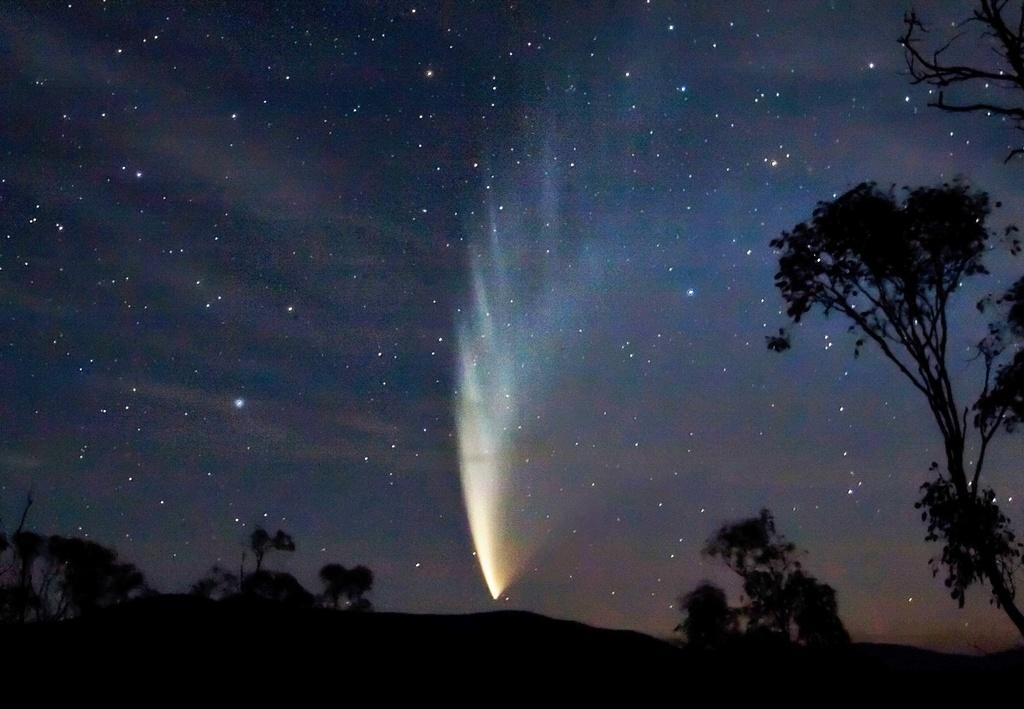What type of vegetation can be seen at the bottom of the image? There are trees at the bottom side of the image. What else can be seen on the right side of the image? There are trees on the right side of the image. What celestial objects are visible in the sky? Stars are visible in the sky. What is the source of light in the sky? There is light in the sky. Can you hear the cherry playing music in the image? There is no cherry or music present in the image. How many ears can be seen on the trees in the image? Trees do not have ears, so this question cannot be answered based on the image. 